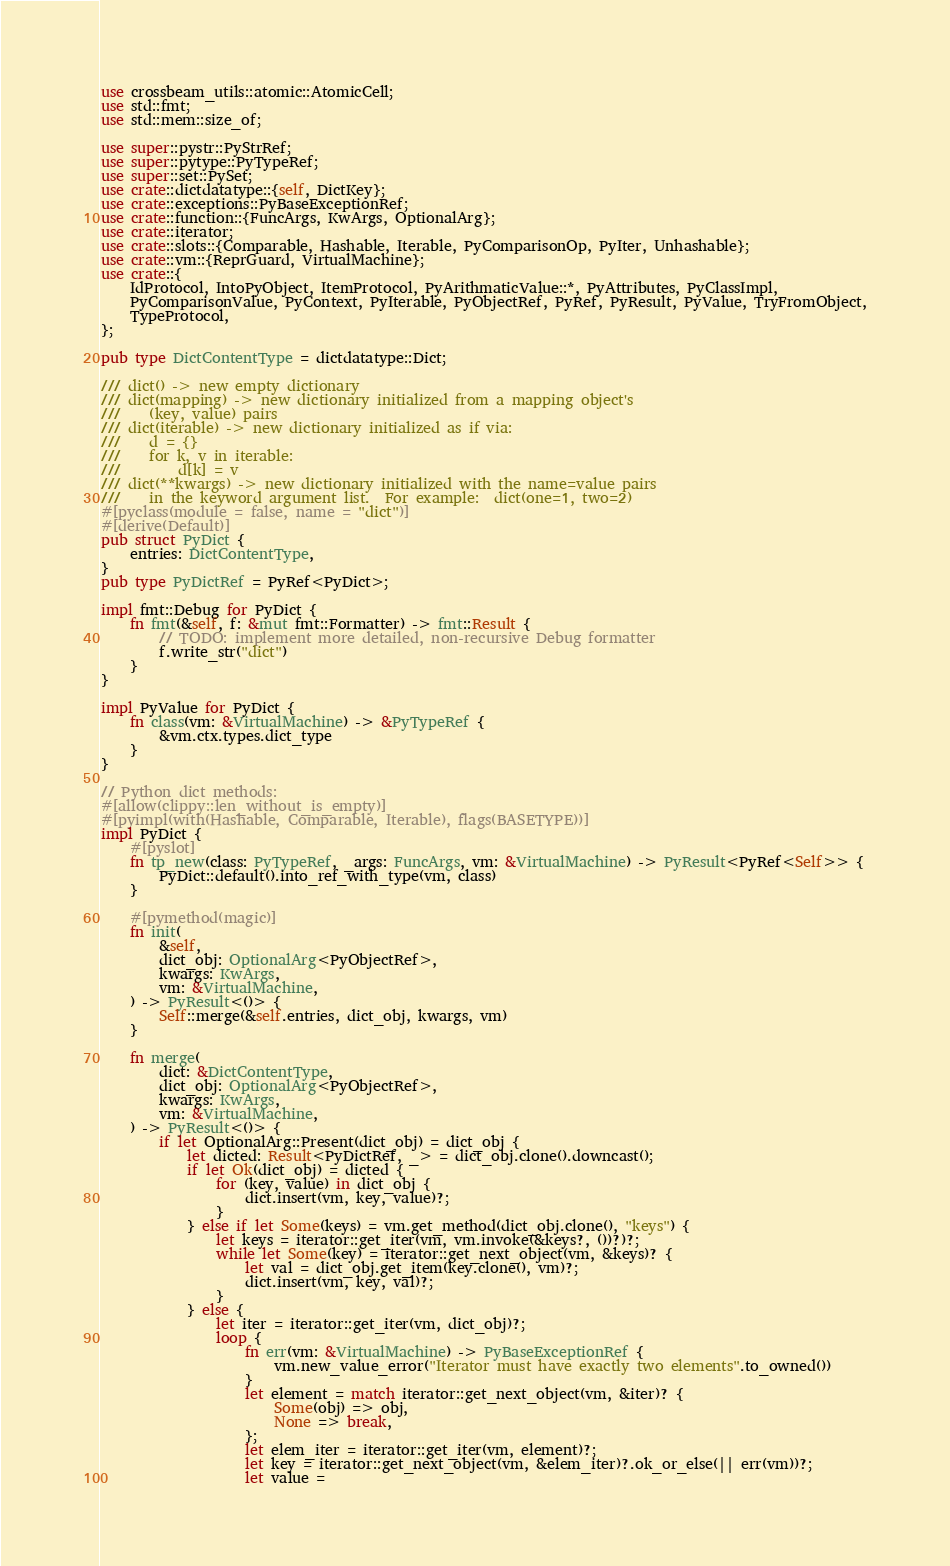Convert code to text. <code><loc_0><loc_0><loc_500><loc_500><_Rust_>use crossbeam_utils::atomic::AtomicCell;
use std::fmt;
use std::mem::size_of;

use super::pystr::PyStrRef;
use super::pytype::PyTypeRef;
use super::set::PySet;
use crate::dictdatatype::{self, DictKey};
use crate::exceptions::PyBaseExceptionRef;
use crate::function::{FuncArgs, KwArgs, OptionalArg};
use crate::iterator;
use crate::slots::{Comparable, Hashable, Iterable, PyComparisonOp, PyIter, Unhashable};
use crate::vm::{ReprGuard, VirtualMachine};
use crate::{
    IdProtocol, IntoPyObject, ItemProtocol, PyArithmaticValue::*, PyAttributes, PyClassImpl,
    PyComparisonValue, PyContext, PyIterable, PyObjectRef, PyRef, PyResult, PyValue, TryFromObject,
    TypeProtocol,
};

pub type DictContentType = dictdatatype::Dict;

/// dict() -> new empty dictionary
/// dict(mapping) -> new dictionary initialized from a mapping object's
///    (key, value) pairs
/// dict(iterable) -> new dictionary initialized as if via:
///    d = {}
///    for k, v in iterable:
///        d[k] = v
/// dict(**kwargs) -> new dictionary initialized with the name=value pairs
///    in the keyword argument list.  For example:  dict(one=1, two=2)
#[pyclass(module = false, name = "dict")]
#[derive(Default)]
pub struct PyDict {
    entries: DictContentType,
}
pub type PyDictRef = PyRef<PyDict>;

impl fmt::Debug for PyDict {
    fn fmt(&self, f: &mut fmt::Formatter) -> fmt::Result {
        // TODO: implement more detailed, non-recursive Debug formatter
        f.write_str("dict")
    }
}

impl PyValue for PyDict {
    fn class(vm: &VirtualMachine) -> &PyTypeRef {
        &vm.ctx.types.dict_type
    }
}

// Python dict methods:
#[allow(clippy::len_without_is_empty)]
#[pyimpl(with(Hashable, Comparable, Iterable), flags(BASETYPE))]
impl PyDict {
    #[pyslot]
    fn tp_new(class: PyTypeRef, _args: FuncArgs, vm: &VirtualMachine) -> PyResult<PyRef<Self>> {
        PyDict::default().into_ref_with_type(vm, class)
    }

    #[pymethod(magic)]
    fn init(
        &self,
        dict_obj: OptionalArg<PyObjectRef>,
        kwargs: KwArgs,
        vm: &VirtualMachine,
    ) -> PyResult<()> {
        Self::merge(&self.entries, dict_obj, kwargs, vm)
    }

    fn merge(
        dict: &DictContentType,
        dict_obj: OptionalArg<PyObjectRef>,
        kwargs: KwArgs,
        vm: &VirtualMachine,
    ) -> PyResult<()> {
        if let OptionalArg::Present(dict_obj) = dict_obj {
            let dicted: Result<PyDictRef, _> = dict_obj.clone().downcast();
            if let Ok(dict_obj) = dicted {
                for (key, value) in dict_obj {
                    dict.insert(vm, key, value)?;
                }
            } else if let Some(keys) = vm.get_method(dict_obj.clone(), "keys") {
                let keys = iterator::get_iter(vm, vm.invoke(&keys?, ())?)?;
                while let Some(key) = iterator::get_next_object(vm, &keys)? {
                    let val = dict_obj.get_item(key.clone(), vm)?;
                    dict.insert(vm, key, val)?;
                }
            } else {
                let iter = iterator::get_iter(vm, dict_obj)?;
                loop {
                    fn err(vm: &VirtualMachine) -> PyBaseExceptionRef {
                        vm.new_value_error("Iterator must have exactly two elements".to_owned())
                    }
                    let element = match iterator::get_next_object(vm, &iter)? {
                        Some(obj) => obj,
                        None => break,
                    };
                    let elem_iter = iterator::get_iter(vm, element)?;
                    let key = iterator::get_next_object(vm, &elem_iter)?.ok_or_else(|| err(vm))?;
                    let value =</code> 